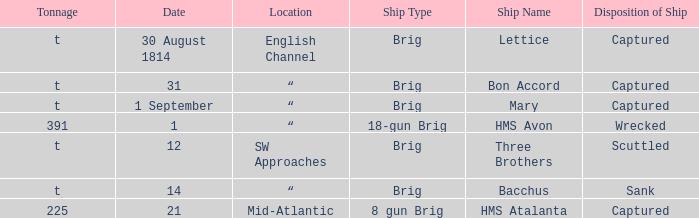The ship named Bacchus with a tonnage of t had what disposition of ship? Sank. 